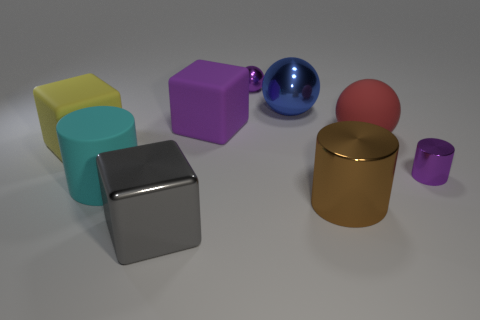There is a block that is the same color as the small metal ball; what material is it?
Make the answer very short. Rubber. What number of other things are the same material as the tiny cylinder?
Offer a very short reply. 4. What number of cubes have the same color as the large metal cylinder?
Keep it short and to the point. 0. There is a ball in front of the cube right of the large cube in front of the brown object; what is its size?
Provide a succinct answer. Large. How many rubber things are cyan objects or small cylinders?
Provide a succinct answer. 1. There is a cyan object; does it have the same shape as the big gray metal object that is in front of the big red object?
Your answer should be very brief. No. Is the number of blue spheres right of the purple block greater than the number of objects right of the yellow cube?
Make the answer very short. No. Is there anything else that is the same color as the small shiny cylinder?
Offer a very short reply. Yes. There is a metal ball that is on the right side of the purple shiny thing that is behind the blue metallic sphere; are there any small objects that are in front of it?
Keep it short and to the point. Yes. There is a big object behind the large purple object; does it have the same shape as the big cyan object?
Provide a short and direct response. No. 